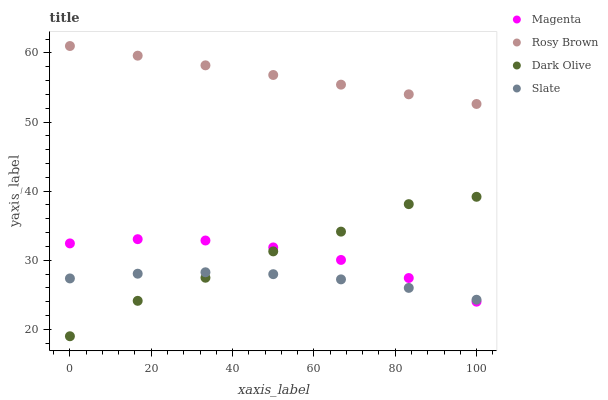Does Slate have the minimum area under the curve?
Answer yes or no. Yes. Does Rosy Brown have the maximum area under the curve?
Answer yes or no. Yes. Does Magenta have the minimum area under the curve?
Answer yes or no. No. Does Magenta have the maximum area under the curve?
Answer yes or no. No. Is Rosy Brown the smoothest?
Answer yes or no. Yes. Is Dark Olive the roughest?
Answer yes or no. Yes. Is Magenta the smoothest?
Answer yes or no. No. Is Magenta the roughest?
Answer yes or no. No. Does Dark Olive have the lowest value?
Answer yes or no. Yes. Does Magenta have the lowest value?
Answer yes or no. No. Does Rosy Brown have the highest value?
Answer yes or no. Yes. Does Magenta have the highest value?
Answer yes or no. No. Is Slate less than Rosy Brown?
Answer yes or no. Yes. Is Rosy Brown greater than Magenta?
Answer yes or no. Yes. Does Dark Olive intersect Slate?
Answer yes or no. Yes. Is Dark Olive less than Slate?
Answer yes or no. No. Is Dark Olive greater than Slate?
Answer yes or no. No. Does Slate intersect Rosy Brown?
Answer yes or no. No. 